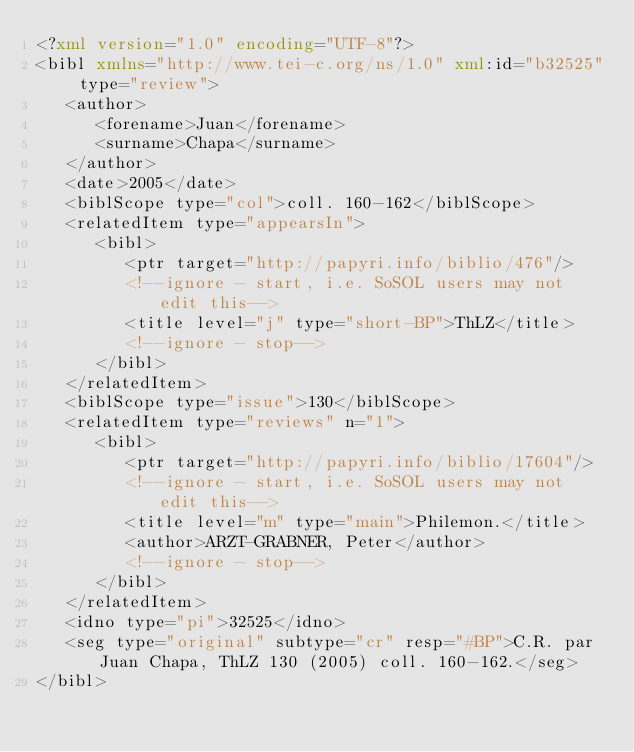Convert code to text. <code><loc_0><loc_0><loc_500><loc_500><_XML_><?xml version="1.0" encoding="UTF-8"?>
<bibl xmlns="http://www.tei-c.org/ns/1.0" xml:id="b32525" type="review">
   <author>
      <forename>Juan</forename>
      <surname>Chapa</surname>
   </author>
   <date>2005</date>
   <biblScope type="col">coll. 160-162</biblScope>
   <relatedItem type="appearsIn">
      <bibl>
         <ptr target="http://papyri.info/biblio/476"/>
         <!--ignore - start, i.e. SoSOL users may not edit this-->
         <title level="j" type="short-BP">ThLZ</title>
         <!--ignore - stop-->
      </bibl>
   </relatedItem>
   <biblScope type="issue">130</biblScope>
   <relatedItem type="reviews" n="1">
      <bibl>
         <ptr target="http://papyri.info/biblio/17604"/>
         <!--ignore - start, i.e. SoSOL users may not edit this-->
         <title level="m" type="main">Philemon.</title>
         <author>ARZT-GRABNER, Peter</author>
         <!--ignore - stop-->
      </bibl>
   </relatedItem>
   <idno type="pi">32525</idno>
   <seg type="original" subtype="cr" resp="#BP">C.R. par Juan Chapa, ThLZ 130 (2005) coll. 160-162.</seg>
</bibl>
</code> 